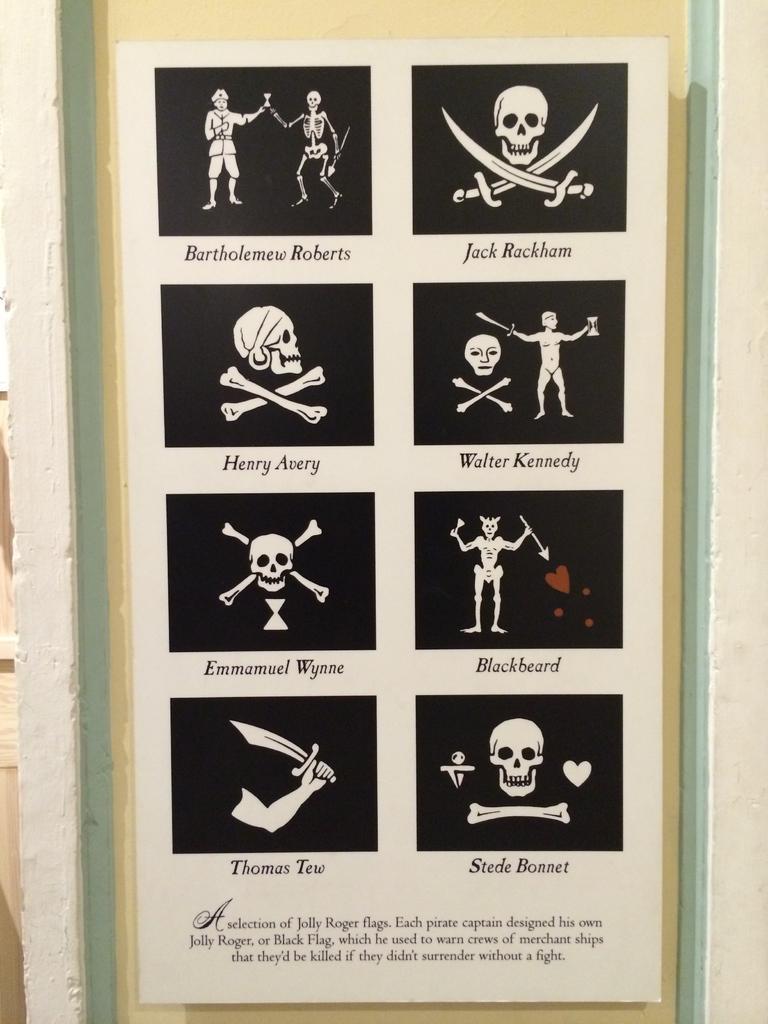Please provide a concise description of this image. In this picture we can see a photo frame with some skull images and text on the wall. 